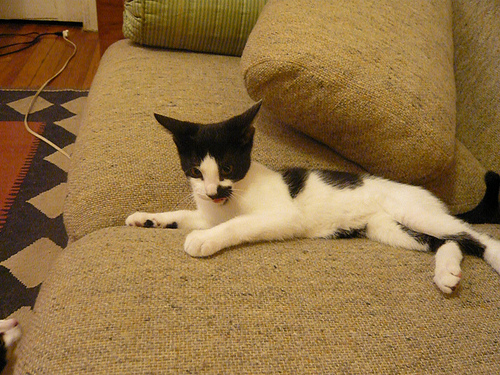<image>
Is there a cat behind the pillow? No. The cat is not behind the pillow. From this viewpoint, the cat appears to be positioned elsewhere in the scene. Where is the cat in relation to the couch? Is it in the couch? No. The cat is not contained within the couch. These objects have a different spatial relationship. 